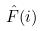Convert formula to latex. <formula><loc_0><loc_0><loc_500><loc_500>\hat { F } ( i )</formula> 